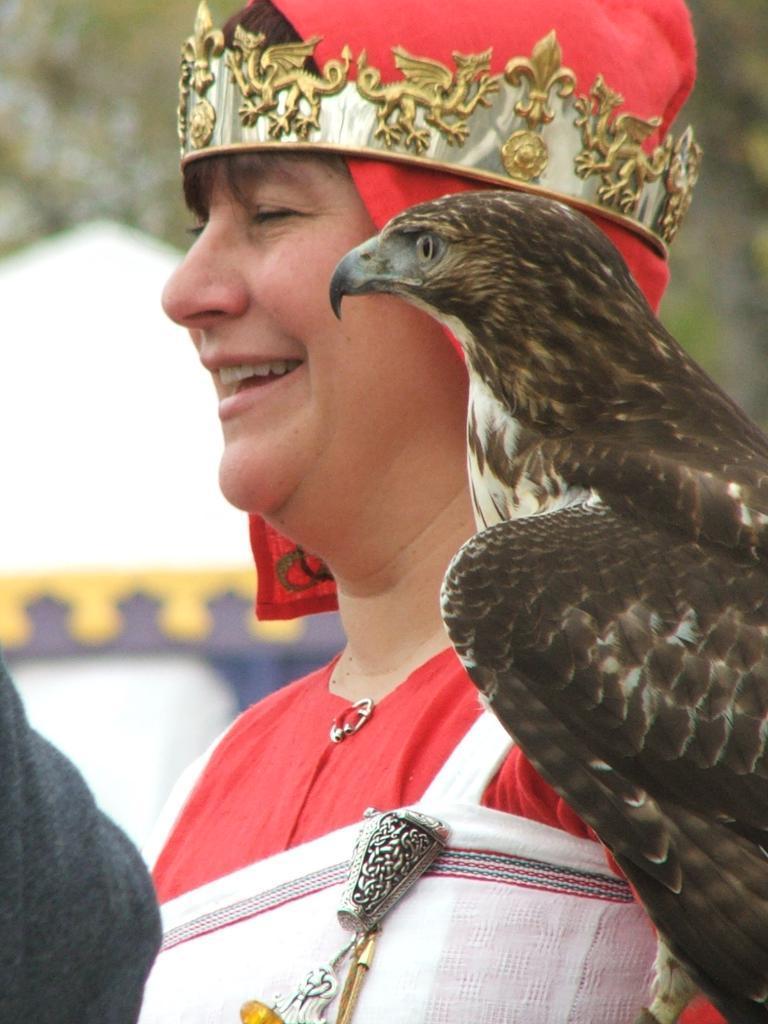Please provide a concise description of this image. In the image there is person in red dress and crown over his head with a eagle on his shoulder and in the back there is a tree. 